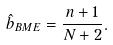<formula> <loc_0><loc_0><loc_500><loc_500>\hat { b } _ { B M E } = \frac { n + 1 } { N + 2 } .</formula> 